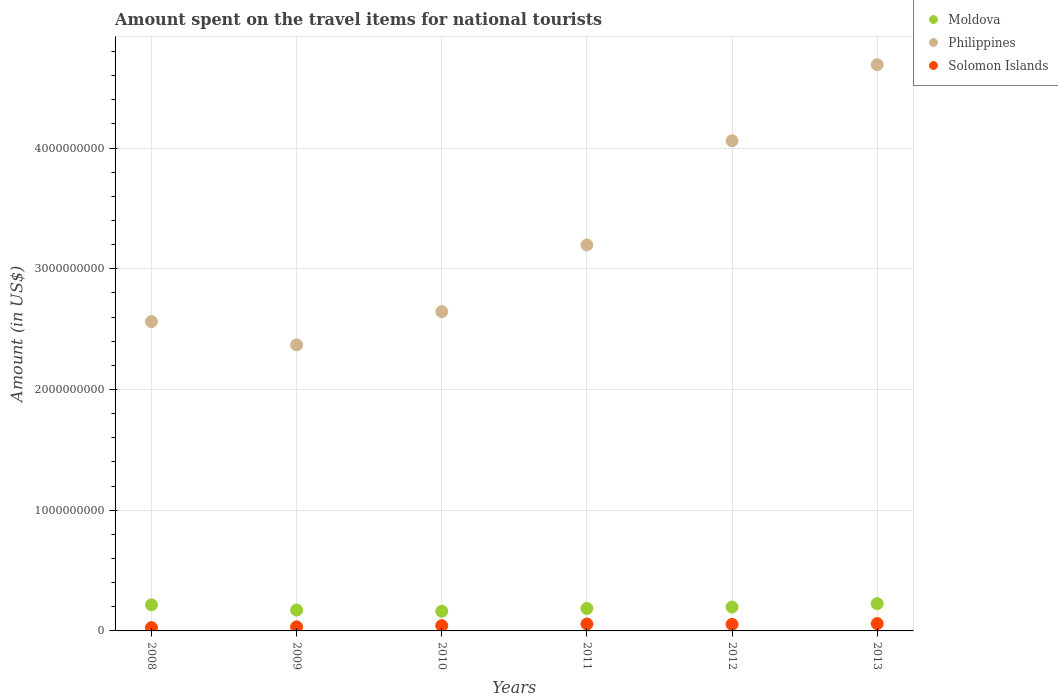How many different coloured dotlines are there?
Provide a succinct answer. 3. What is the amount spent on the travel items for national tourists in Solomon Islands in 2013?
Offer a very short reply. 6.06e+07. Across all years, what is the maximum amount spent on the travel items for national tourists in Solomon Islands?
Provide a short and direct response. 6.06e+07. Across all years, what is the minimum amount spent on the travel items for national tourists in Moldova?
Offer a very short reply. 1.63e+08. What is the total amount spent on the travel items for national tourists in Philippines in the graph?
Make the answer very short. 1.95e+1. What is the difference between the amount spent on the travel items for national tourists in Solomon Islands in 2008 and that in 2010?
Ensure brevity in your answer.  -1.60e+07. What is the difference between the amount spent on the travel items for national tourists in Moldova in 2011 and the amount spent on the travel items for national tourists in Solomon Islands in 2008?
Give a very brief answer. 1.58e+08. What is the average amount spent on the travel items for national tourists in Solomon Islands per year?
Make the answer very short. 4.61e+07. In the year 2009, what is the difference between the amount spent on the travel items for national tourists in Philippines and amount spent on the travel items for national tourists in Solomon Islands?
Your answer should be compact. 2.34e+09. What is the ratio of the amount spent on the travel items for national tourists in Philippines in 2008 to that in 2009?
Your answer should be compact. 1.08. What is the difference between the highest and the second highest amount spent on the travel items for national tourists in Moldova?
Offer a very short reply. 1.00e+07. What is the difference between the highest and the lowest amount spent on the travel items for national tourists in Philippines?
Keep it short and to the point. 2.32e+09. Is it the case that in every year, the sum of the amount spent on the travel items for national tourists in Philippines and amount spent on the travel items for national tourists in Solomon Islands  is greater than the amount spent on the travel items for national tourists in Moldova?
Offer a very short reply. Yes. Is the amount spent on the travel items for national tourists in Philippines strictly greater than the amount spent on the travel items for national tourists in Solomon Islands over the years?
Give a very brief answer. Yes. Is the amount spent on the travel items for national tourists in Philippines strictly less than the amount spent on the travel items for national tourists in Moldova over the years?
Provide a succinct answer. No. How many dotlines are there?
Offer a terse response. 3. Are the values on the major ticks of Y-axis written in scientific E-notation?
Offer a terse response. No. Does the graph contain grids?
Make the answer very short. Yes. How many legend labels are there?
Provide a short and direct response. 3. How are the legend labels stacked?
Give a very brief answer. Vertical. What is the title of the graph?
Keep it short and to the point. Amount spent on the travel items for national tourists. Does "Lesotho" appear as one of the legend labels in the graph?
Give a very brief answer. No. What is the Amount (in US$) in Moldova in 2008?
Your answer should be compact. 2.16e+08. What is the Amount (in US$) of Philippines in 2008?
Make the answer very short. 2.56e+09. What is the Amount (in US$) of Solomon Islands in 2008?
Make the answer very short. 2.75e+07. What is the Amount (in US$) in Moldova in 2009?
Keep it short and to the point. 1.73e+08. What is the Amount (in US$) of Philippines in 2009?
Your answer should be very brief. 2.37e+09. What is the Amount (in US$) in Solomon Islands in 2009?
Make the answer very short. 3.34e+07. What is the Amount (in US$) in Moldova in 2010?
Provide a succinct answer. 1.63e+08. What is the Amount (in US$) of Philippines in 2010?
Ensure brevity in your answer.  2.64e+09. What is the Amount (in US$) of Solomon Islands in 2010?
Your answer should be very brief. 4.35e+07. What is the Amount (in US$) of Moldova in 2011?
Provide a succinct answer. 1.86e+08. What is the Amount (in US$) of Philippines in 2011?
Provide a short and direct response. 3.20e+09. What is the Amount (in US$) of Solomon Islands in 2011?
Your response must be concise. 5.73e+07. What is the Amount (in US$) in Moldova in 2012?
Offer a terse response. 1.98e+08. What is the Amount (in US$) in Philippines in 2012?
Give a very brief answer. 4.06e+09. What is the Amount (in US$) in Solomon Islands in 2012?
Your answer should be compact. 5.41e+07. What is the Amount (in US$) in Moldova in 2013?
Make the answer very short. 2.26e+08. What is the Amount (in US$) of Philippines in 2013?
Your answer should be very brief. 4.69e+09. What is the Amount (in US$) of Solomon Islands in 2013?
Provide a succinct answer. 6.06e+07. Across all years, what is the maximum Amount (in US$) in Moldova?
Your answer should be compact. 2.26e+08. Across all years, what is the maximum Amount (in US$) of Philippines?
Your answer should be very brief. 4.69e+09. Across all years, what is the maximum Amount (in US$) in Solomon Islands?
Offer a terse response. 6.06e+07. Across all years, what is the minimum Amount (in US$) of Moldova?
Ensure brevity in your answer.  1.63e+08. Across all years, what is the minimum Amount (in US$) of Philippines?
Provide a short and direct response. 2.37e+09. Across all years, what is the minimum Amount (in US$) in Solomon Islands?
Give a very brief answer. 2.75e+07. What is the total Amount (in US$) in Moldova in the graph?
Provide a succinct answer. 1.16e+09. What is the total Amount (in US$) in Philippines in the graph?
Your response must be concise. 1.95e+1. What is the total Amount (in US$) in Solomon Islands in the graph?
Give a very brief answer. 2.76e+08. What is the difference between the Amount (in US$) of Moldova in 2008 and that in 2009?
Offer a terse response. 4.30e+07. What is the difference between the Amount (in US$) in Philippines in 2008 and that in 2009?
Ensure brevity in your answer.  1.93e+08. What is the difference between the Amount (in US$) in Solomon Islands in 2008 and that in 2009?
Provide a short and direct response. -5.90e+06. What is the difference between the Amount (in US$) of Moldova in 2008 and that in 2010?
Keep it short and to the point. 5.30e+07. What is the difference between the Amount (in US$) in Philippines in 2008 and that in 2010?
Keep it short and to the point. -8.20e+07. What is the difference between the Amount (in US$) of Solomon Islands in 2008 and that in 2010?
Offer a terse response. -1.60e+07. What is the difference between the Amount (in US$) in Moldova in 2008 and that in 2011?
Your response must be concise. 3.00e+07. What is the difference between the Amount (in US$) in Philippines in 2008 and that in 2011?
Keep it short and to the point. -6.35e+08. What is the difference between the Amount (in US$) of Solomon Islands in 2008 and that in 2011?
Keep it short and to the point. -2.98e+07. What is the difference between the Amount (in US$) in Moldova in 2008 and that in 2012?
Ensure brevity in your answer.  1.80e+07. What is the difference between the Amount (in US$) of Philippines in 2008 and that in 2012?
Offer a terse response. -1.50e+09. What is the difference between the Amount (in US$) in Solomon Islands in 2008 and that in 2012?
Your response must be concise. -2.66e+07. What is the difference between the Amount (in US$) of Moldova in 2008 and that in 2013?
Make the answer very short. -1.00e+07. What is the difference between the Amount (in US$) in Philippines in 2008 and that in 2013?
Ensure brevity in your answer.  -2.13e+09. What is the difference between the Amount (in US$) of Solomon Islands in 2008 and that in 2013?
Your answer should be compact. -3.31e+07. What is the difference between the Amount (in US$) of Moldova in 2009 and that in 2010?
Your answer should be compact. 1.00e+07. What is the difference between the Amount (in US$) of Philippines in 2009 and that in 2010?
Give a very brief answer. -2.75e+08. What is the difference between the Amount (in US$) in Solomon Islands in 2009 and that in 2010?
Offer a terse response. -1.01e+07. What is the difference between the Amount (in US$) of Moldova in 2009 and that in 2011?
Provide a succinct answer. -1.30e+07. What is the difference between the Amount (in US$) of Philippines in 2009 and that in 2011?
Your response must be concise. -8.28e+08. What is the difference between the Amount (in US$) of Solomon Islands in 2009 and that in 2011?
Your answer should be compact. -2.39e+07. What is the difference between the Amount (in US$) in Moldova in 2009 and that in 2012?
Your response must be concise. -2.50e+07. What is the difference between the Amount (in US$) of Philippines in 2009 and that in 2012?
Offer a very short reply. -1.69e+09. What is the difference between the Amount (in US$) of Solomon Islands in 2009 and that in 2012?
Your response must be concise. -2.07e+07. What is the difference between the Amount (in US$) of Moldova in 2009 and that in 2013?
Offer a very short reply. -5.30e+07. What is the difference between the Amount (in US$) in Philippines in 2009 and that in 2013?
Offer a very short reply. -2.32e+09. What is the difference between the Amount (in US$) in Solomon Islands in 2009 and that in 2013?
Offer a terse response. -2.72e+07. What is the difference between the Amount (in US$) of Moldova in 2010 and that in 2011?
Your answer should be very brief. -2.30e+07. What is the difference between the Amount (in US$) of Philippines in 2010 and that in 2011?
Offer a very short reply. -5.53e+08. What is the difference between the Amount (in US$) of Solomon Islands in 2010 and that in 2011?
Provide a short and direct response. -1.38e+07. What is the difference between the Amount (in US$) of Moldova in 2010 and that in 2012?
Your answer should be compact. -3.50e+07. What is the difference between the Amount (in US$) of Philippines in 2010 and that in 2012?
Provide a succinct answer. -1.42e+09. What is the difference between the Amount (in US$) in Solomon Islands in 2010 and that in 2012?
Offer a very short reply. -1.06e+07. What is the difference between the Amount (in US$) of Moldova in 2010 and that in 2013?
Provide a short and direct response. -6.30e+07. What is the difference between the Amount (in US$) in Philippines in 2010 and that in 2013?
Offer a terse response. -2.05e+09. What is the difference between the Amount (in US$) in Solomon Islands in 2010 and that in 2013?
Offer a very short reply. -1.71e+07. What is the difference between the Amount (in US$) of Moldova in 2011 and that in 2012?
Ensure brevity in your answer.  -1.20e+07. What is the difference between the Amount (in US$) in Philippines in 2011 and that in 2012?
Ensure brevity in your answer.  -8.63e+08. What is the difference between the Amount (in US$) in Solomon Islands in 2011 and that in 2012?
Ensure brevity in your answer.  3.20e+06. What is the difference between the Amount (in US$) in Moldova in 2011 and that in 2013?
Provide a succinct answer. -4.00e+07. What is the difference between the Amount (in US$) of Philippines in 2011 and that in 2013?
Make the answer very short. -1.49e+09. What is the difference between the Amount (in US$) of Solomon Islands in 2011 and that in 2013?
Provide a short and direct response. -3.30e+06. What is the difference between the Amount (in US$) in Moldova in 2012 and that in 2013?
Offer a very short reply. -2.80e+07. What is the difference between the Amount (in US$) in Philippines in 2012 and that in 2013?
Provide a succinct answer. -6.30e+08. What is the difference between the Amount (in US$) in Solomon Islands in 2012 and that in 2013?
Keep it short and to the point. -6.50e+06. What is the difference between the Amount (in US$) in Moldova in 2008 and the Amount (in US$) in Philippines in 2009?
Provide a succinct answer. -2.15e+09. What is the difference between the Amount (in US$) in Moldova in 2008 and the Amount (in US$) in Solomon Islands in 2009?
Provide a succinct answer. 1.83e+08. What is the difference between the Amount (in US$) in Philippines in 2008 and the Amount (in US$) in Solomon Islands in 2009?
Provide a short and direct response. 2.53e+09. What is the difference between the Amount (in US$) in Moldova in 2008 and the Amount (in US$) in Philippines in 2010?
Make the answer very short. -2.43e+09. What is the difference between the Amount (in US$) of Moldova in 2008 and the Amount (in US$) of Solomon Islands in 2010?
Offer a terse response. 1.72e+08. What is the difference between the Amount (in US$) in Philippines in 2008 and the Amount (in US$) in Solomon Islands in 2010?
Ensure brevity in your answer.  2.52e+09. What is the difference between the Amount (in US$) in Moldova in 2008 and the Amount (in US$) in Philippines in 2011?
Give a very brief answer. -2.98e+09. What is the difference between the Amount (in US$) of Moldova in 2008 and the Amount (in US$) of Solomon Islands in 2011?
Your response must be concise. 1.59e+08. What is the difference between the Amount (in US$) in Philippines in 2008 and the Amount (in US$) in Solomon Islands in 2011?
Offer a terse response. 2.51e+09. What is the difference between the Amount (in US$) of Moldova in 2008 and the Amount (in US$) of Philippines in 2012?
Give a very brief answer. -3.84e+09. What is the difference between the Amount (in US$) in Moldova in 2008 and the Amount (in US$) in Solomon Islands in 2012?
Provide a succinct answer. 1.62e+08. What is the difference between the Amount (in US$) of Philippines in 2008 and the Amount (in US$) of Solomon Islands in 2012?
Offer a terse response. 2.51e+09. What is the difference between the Amount (in US$) of Moldova in 2008 and the Amount (in US$) of Philippines in 2013?
Provide a short and direct response. -4.48e+09. What is the difference between the Amount (in US$) of Moldova in 2008 and the Amount (in US$) of Solomon Islands in 2013?
Offer a very short reply. 1.55e+08. What is the difference between the Amount (in US$) in Philippines in 2008 and the Amount (in US$) in Solomon Islands in 2013?
Your response must be concise. 2.50e+09. What is the difference between the Amount (in US$) of Moldova in 2009 and the Amount (in US$) of Philippines in 2010?
Your response must be concise. -2.47e+09. What is the difference between the Amount (in US$) of Moldova in 2009 and the Amount (in US$) of Solomon Islands in 2010?
Keep it short and to the point. 1.30e+08. What is the difference between the Amount (in US$) of Philippines in 2009 and the Amount (in US$) of Solomon Islands in 2010?
Your answer should be compact. 2.33e+09. What is the difference between the Amount (in US$) in Moldova in 2009 and the Amount (in US$) in Philippines in 2011?
Keep it short and to the point. -3.02e+09. What is the difference between the Amount (in US$) in Moldova in 2009 and the Amount (in US$) in Solomon Islands in 2011?
Ensure brevity in your answer.  1.16e+08. What is the difference between the Amount (in US$) in Philippines in 2009 and the Amount (in US$) in Solomon Islands in 2011?
Keep it short and to the point. 2.31e+09. What is the difference between the Amount (in US$) in Moldova in 2009 and the Amount (in US$) in Philippines in 2012?
Give a very brief answer. -3.89e+09. What is the difference between the Amount (in US$) of Moldova in 2009 and the Amount (in US$) of Solomon Islands in 2012?
Your response must be concise. 1.19e+08. What is the difference between the Amount (in US$) in Philippines in 2009 and the Amount (in US$) in Solomon Islands in 2012?
Make the answer very short. 2.32e+09. What is the difference between the Amount (in US$) in Moldova in 2009 and the Amount (in US$) in Philippines in 2013?
Provide a short and direct response. -4.52e+09. What is the difference between the Amount (in US$) of Moldova in 2009 and the Amount (in US$) of Solomon Islands in 2013?
Offer a terse response. 1.12e+08. What is the difference between the Amount (in US$) in Philippines in 2009 and the Amount (in US$) in Solomon Islands in 2013?
Your answer should be compact. 2.31e+09. What is the difference between the Amount (in US$) in Moldova in 2010 and the Amount (in US$) in Philippines in 2011?
Give a very brief answer. -3.04e+09. What is the difference between the Amount (in US$) in Moldova in 2010 and the Amount (in US$) in Solomon Islands in 2011?
Make the answer very short. 1.06e+08. What is the difference between the Amount (in US$) in Philippines in 2010 and the Amount (in US$) in Solomon Islands in 2011?
Provide a short and direct response. 2.59e+09. What is the difference between the Amount (in US$) of Moldova in 2010 and the Amount (in US$) of Philippines in 2012?
Provide a succinct answer. -3.90e+09. What is the difference between the Amount (in US$) in Moldova in 2010 and the Amount (in US$) in Solomon Islands in 2012?
Keep it short and to the point. 1.09e+08. What is the difference between the Amount (in US$) in Philippines in 2010 and the Amount (in US$) in Solomon Islands in 2012?
Your answer should be very brief. 2.59e+09. What is the difference between the Amount (in US$) of Moldova in 2010 and the Amount (in US$) of Philippines in 2013?
Provide a succinct answer. -4.53e+09. What is the difference between the Amount (in US$) in Moldova in 2010 and the Amount (in US$) in Solomon Islands in 2013?
Your answer should be compact. 1.02e+08. What is the difference between the Amount (in US$) of Philippines in 2010 and the Amount (in US$) of Solomon Islands in 2013?
Give a very brief answer. 2.58e+09. What is the difference between the Amount (in US$) of Moldova in 2011 and the Amount (in US$) of Philippines in 2012?
Your answer should be compact. -3.88e+09. What is the difference between the Amount (in US$) in Moldova in 2011 and the Amount (in US$) in Solomon Islands in 2012?
Your answer should be very brief. 1.32e+08. What is the difference between the Amount (in US$) of Philippines in 2011 and the Amount (in US$) of Solomon Islands in 2012?
Your response must be concise. 3.14e+09. What is the difference between the Amount (in US$) of Moldova in 2011 and the Amount (in US$) of Philippines in 2013?
Give a very brief answer. -4.50e+09. What is the difference between the Amount (in US$) of Moldova in 2011 and the Amount (in US$) of Solomon Islands in 2013?
Offer a very short reply. 1.25e+08. What is the difference between the Amount (in US$) in Philippines in 2011 and the Amount (in US$) in Solomon Islands in 2013?
Provide a short and direct response. 3.14e+09. What is the difference between the Amount (in US$) of Moldova in 2012 and the Amount (in US$) of Philippines in 2013?
Keep it short and to the point. -4.49e+09. What is the difference between the Amount (in US$) in Moldova in 2012 and the Amount (in US$) in Solomon Islands in 2013?
Your answer should be very brief. 1.37e+08. What is the difference between the Amount (in US$) of Philippines in 2012 and the Amount (in US$) of Solomon Islands in 2013?
Offer a terse response. 4.00e+09. What is the average Amount (in US$) in Moldova per year?
Provide a short and direct response. 1.94e+08. What is the average Amount (in US$) in Philippines per year?
Your answer should be compact. 3.25e+09. What is the average Amount (in US$) of Solomon Islands per year?
Your response must be concise. 4.61e+07. In the year 2008, what is the difference between the Amount (in US$) of Moldova and Amount (in US$) of Philippines?
Your answer should be very brief. -2.35e+09. In the year 2008, what is the difference between the Amount (in US$) in Moldova and Amount (in US$) in Solomon Islands?
Your response must be concise. 1.88e+08. In the year 2008, what is the difference between the Amount (in US$) in Philippines and Amount (in US$) in Solomon Islands?
Make the answer very short. 2.54e+09. In the year 2009, what is the difference between the Amount (in US$) of Moldova and Amount (in US$) of Philippines?
Your answer should be compact. -2.20e+09. In the year 2009, what is the difference between the Amount (in US$) in Moldova and Amount (in US$) in Solomon Islands?
Keep it short and to the point. 1.40e+08. In the year 2009, what is the difference between the Amount (in US$) in Philippines and Amount (in US$) in Solomon Islands?
Make the answer very short. 2.34e+09. In the year 2010, what is the difference between the Amount (in US$) in Moldova and Amount (in US$) in Philippines?
Make the answer very short. -2.48e+09. In the year 2010, what is the difference between the Amount (in US$) in Moldova and Amount (in US$) in Solomon Islands?
Your answer should be very brief. 1.20e+08. In the year 2010, what is the difference between the Amount (in US$) of Philippines and Amount (in US$) of Solomon Islands?
Give a very brief answer. 2.60e+09. In the year 2011, what is the difference between the Amount (in US$) in Moldova and Amount (in US$) in Philippines?
Your answer should be very brief. -3.01e+09. In the year 2011, what is the difference between the Amount (in US$) of Moldova and Amount (in US$) of Solomon Islands?
Ensure brevity in your answer.  1.29e+08. In the year 2011, what is the difference between the Amount (in US$) in Philippines and Amount (in US$) in Solomon Islands?
Keep it short and to the point. 3.14e+09. In the year 2012, what is the difference between the Amount (in US$) in Moldova and Amount (in US$) in Philippines?
Offer a very short reply. -3.86e+09. In the year 2012, what is the difference between the Amount (in US$) of Moldova and Amount (in US$) of Solomon Islands?
Keep it short and to the point. 1.44e+08. In the year 2012, what is the difference between the Amount (in US$) in Philippines and Amount (in US$) in Solomon Islands?
Your response must be concise. 4.01e+09. In the year 2013, what is the difference between the Amount (in US$) of Moldova and Amount (in US$) of Philippines?
Offer a terse response. -4.46e+09. In the year 2013, what is the difference between the Amount (in US$) in Moldova and Amount (in US$) in Solomon Islands?
Ensure brevity in your answer.  1.65e+08. In the year 2013, what is the difference between the Amount (in US$) of Philippines and Amount (in US$) of Solomon Islands?
Your answer should be compact. 4.63e+09. What is the ratio of the Amount (in US$) of Moldova in 2008 to that in 2009?
Provide a succinct answer. 1.25. What is the ratio of the Amount (in US$) in Philippines in 2008 to that in 2009?
Provide a succinct answer. 1.08. What is the ratio of the Amount (in US$) in Solomon Islands in 2008 to that in 2009?
Offer a very short reply. 0.82. What is the ratio of the Amount (in US$) of Moldova in 2008 to that in 2010?
Provide a succinct answer. 1.33. What is the ratio of the Amount (in US$) in Solomon Islands in 2008 to that in 2010?
Provide a short and direct response. 0.63. What is the ratio of the Amount (in US$) of Moldova in 2008 to that in 2011?
Your response must be concise. 1.16. What is the ratio of the Amount (in US$) in Philippines in 2008 to that in 2011?
Give a very brief answer. 0.8. What is the ratio of the Amount (in US$) of Solomon Islands in 2008 to that in 2011?
Give a very brief answer. 0.48. What is the ratio of the Amount (in US$) of Moldova in 2008 to that in 2012?
Make the answer very short. 1.09. What is the ratio of the Amount (in US$) of Philippines in 2008 to that in 2012?
Keep it short and to the point. 0.63. What is the ratio of the Amount (in US$) in Solomon Islands in 2008 to that in 2012?
Offer a very short reply. 0.51. What is the ratio of the Amount (in US$) of Moldova in 2008 to that in 2013?
Your response must be concise. 0.96. What is the ratio of the Amount (in US$) of Philippines in 2008 to that in 2013?
Your answer should be compact. 0.55. What is the ratio of the Amount (in US$) of Solomon Islands in 2008 to that in 2013?
Your answer should be compact. 0.45. What is the ratio of the Amount (in US$) of Moldova in 2009 to that in 2010?
Provide a short and direct response. 1.06. What is the ratio of the Amount (in US$) of Philippines in 2009 to that in 2010?
Offer a very short reply. 0.9. What is the ratio of the Amount (in US$) of Solomon Islands in 2009 to that in 2010?
Your response must be concise. 0.77. What is the ratio of the Amount (in US$) of Moldova in 2009 to that in 2011?
Your answer should be very brief. 0.93. What is the ratio of the Amount (in US$) of Philippines in 2009 to that in 2011?
Offer a very short reply. 0.74. What is the ratio of the Amount (in US$) in Solomon Islands in 2009 to that in 2011?
Offer a very short reply. 0.58. What is the ratio of the Amount (in US$) in Moldova in 2009 to that in 2012?
Offer a very short reply. 0.87. What is the ratio of the Amount (in US$) in Philippines in 2009 to that in 2012?
Make the answer very short. 0.58. What is the ratio of the Amount (in US$) of Solomon Islands in 2009 to that in 2012?
Make the answer very short. 0.62. What is the ratio of the Amount (in US$) of Moldova in 2009 to that in 2013?
Your answer should be very brief. 0.77. What is the ratio of the Amount (in US$) in Philippines in 2009 to that in 2013?
Keep it short and to the point. 0.51. What is the ratio of the Amount (in US$) of Solomon Islands in 2009 to that in 2013?
Provide a short and direct response. 0.55. What is the ratio of the Amount (in US$) in Moldova in 2010 to that in 2011?
Your answer should be compact. 0.88. What is the ratio of the Amount (in US$) of Philippines in 2010 to that in 2011?
Offer a very short reply. 0.83. What is the ratio of the Amount (in US$) of Solomon Islands in 2010 to that in 2011?
Provide a succinct answer. 0.76. What is the ratio of the Amount (in US$) of Moldova in 2010 to that in 2012?
Your response must be concise. 0.82. What is the ratio of the Amount (in US$) in Philippines in 2010 to that in 2012?
Provide a succinct answer. 0.65. What is the ratio of the Amount (in US$) of Solomon Islands in 2010 to that in 2012?
Give a very brief answer. 0.8. What is the ratio of the Amount (in US$) in Moldova in 2010 to that in 2013?
Your response must be concise. 0.72. What is the ratio of the Amount (in US$) of Philippines in 2010 to that in 2013?
Your response must be concise. 0.56. What is the ratio of the Amount (in US$) of Solomon Islands in 2010 to that in 2013?
Provide a succinct answer. 0.72. What is the ratio of the Amount (in US$) in Moldova in 2011 to that in 2012?
Give a very brief answer. 0.94. What is the ratio of the Amount (in US$) in Philippines in 2011 to that in 2012?
Your answer should be very brief. 0.79. What is the ratio of the Amount (in US$) in Solomon Islands in 2011 to that in 2012?
Offer a terse response. 1.06. What is the ratio of the Amount (in US$) of Moldova in 2011 to that in 2013?
Ensure brevity in your answer.  0.82. What is the ratio of the Amount (in US$) in Philippines in 2011 to that in 2013?
Ensure brevity in your answer.  0.68. What is the ratio of the Amount (in US$) in Solomon Islands in 2011 to that in 2013?
Your answer should be compact. 0.95. What is the ratio of the Amount (in US$) of Moldova in 2012 to that in 2013?
Your answer should be compact. 0.88. What is the ratio of the Amount (in US$) in Philippines in 2012 to that in 2013?
Give a very brief answer. 0.87. What is the ratio of the Amount (in US$) in Solomon Islands in 2012 to that in 2013?
Your response must be concise. 0.89. What is the difference between the highest and the second highest Amount (in US$) in Philippines?
Provide a short and direct response. 6.30e+08. What is the difference between the highest and the second highest Amount (in US$) of Solomon Islands?
Your answer should be very brief. 3.30e+06. What is the difference between the highest and the lowest Amount (in US$) in Moldova?
Make the answer very short. 6.30e+07. What is the difference between the highest and the lowest Amount (in US$) in Philippines?
Make the answer very short. 2.32e+09. What is the difference between the highest and the lowest Amount (in US$) in Solomon Islands?
Give a very brief answer. 3.31e+07. 